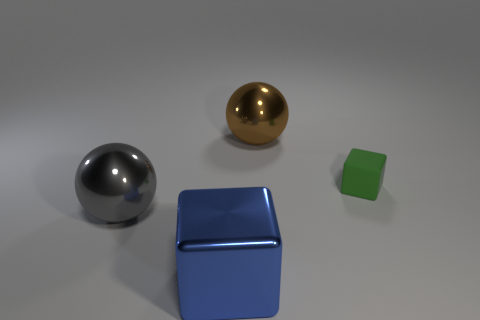Add 2 green things. How many objects exist? 6 Add 3 large brown rubber cylinders. How many large brown rubber cylinders exist? 3 Subtract 0 red cylinders. How many objects are left? 4 Subtract all green matte things. Subtract all green matte cubes. How many objects are left? 2 Add 1 blue objects. How many blue objects are left? 2 